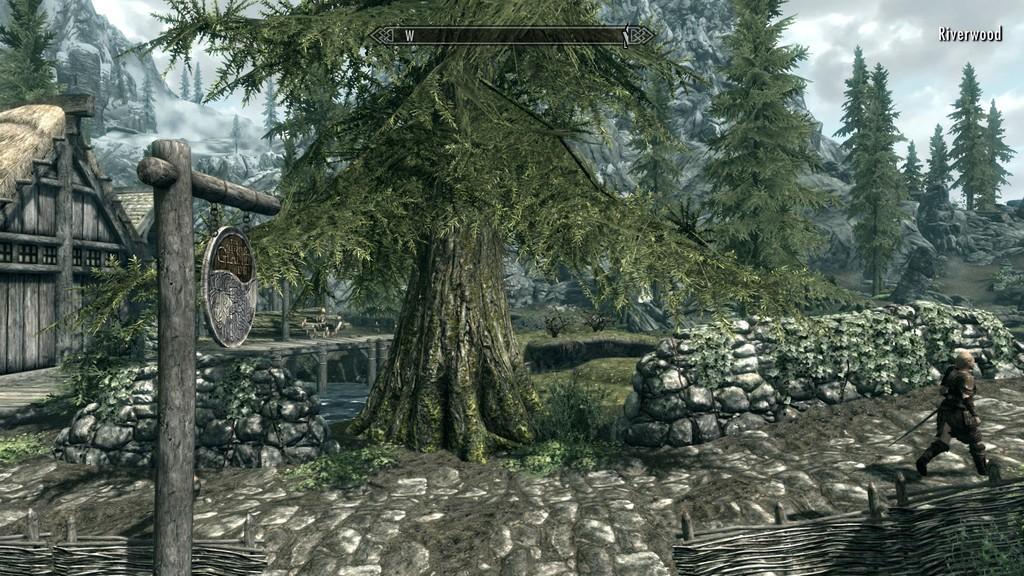In one or two sentences, can you explain what this image depicts? This image is an animation. In the center of the image there are trees. On the left there is a pole and sheds. On the right there is a person. At the bottom there are logs. In the background there are hills and sky. 